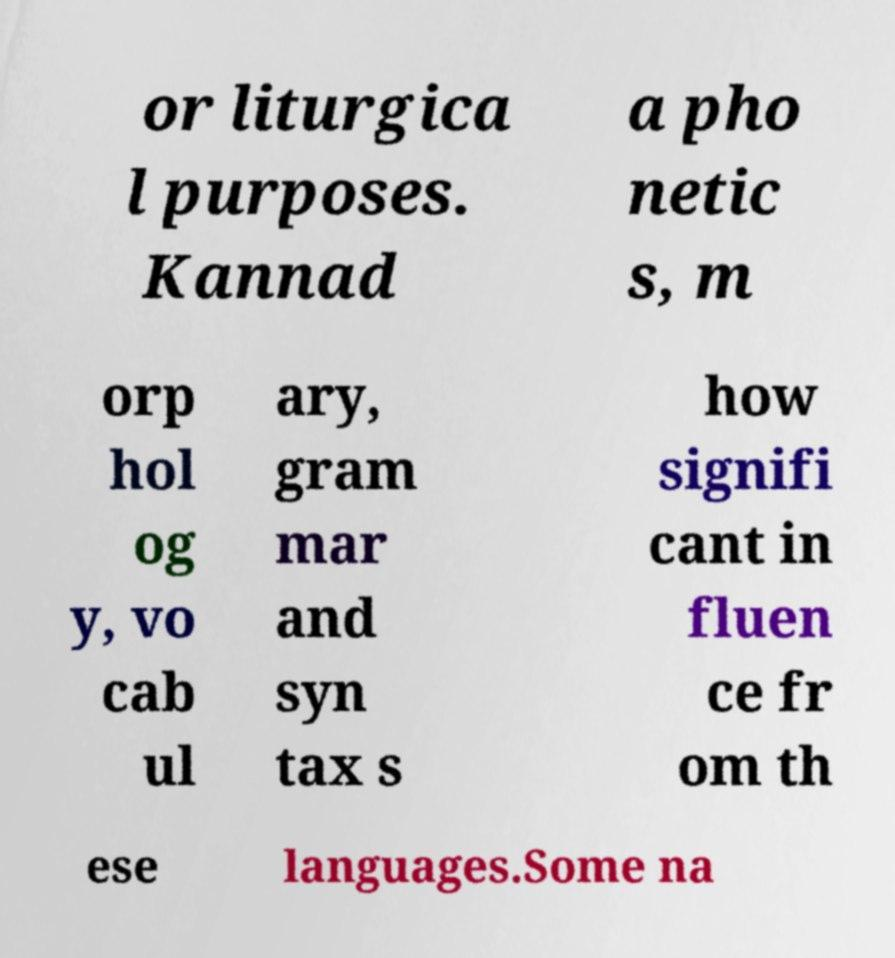Please read and relay the text visible in this image. What does it say? or liturgica l purposes. Kannad a pho netic s, m orp hol og y, vo cab ul ary, gram mar and syn tax s how signifi cant in fluen ce fr om th ese languages.Some na 